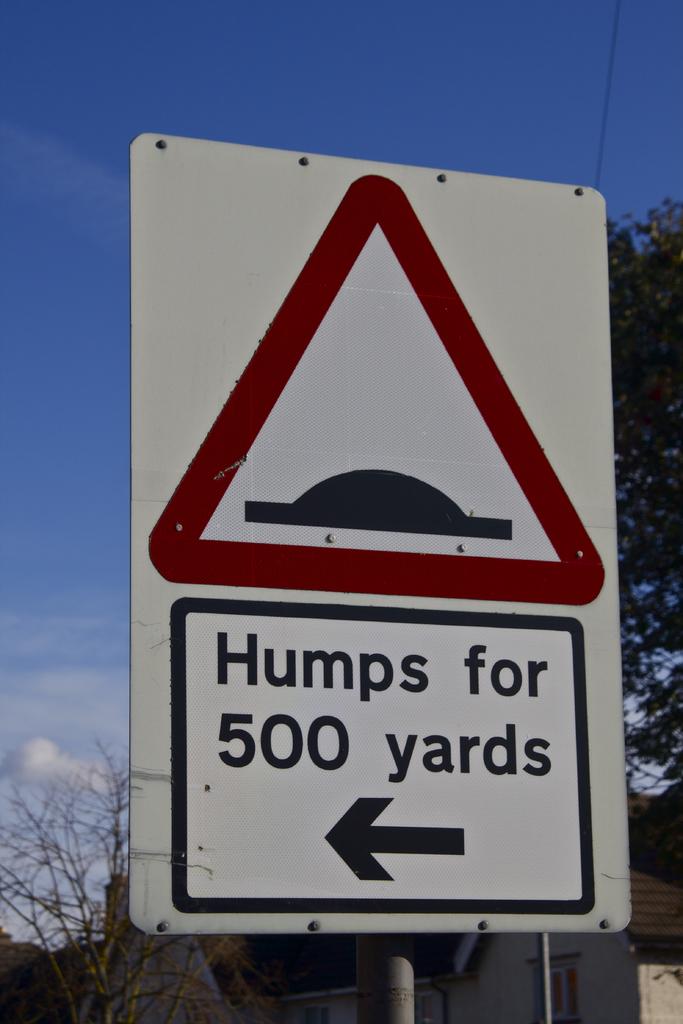How many yards of humps?
Offer a very short reply. 500. What will you find for the next 500 yards?
Offer a terse response. Humps. 